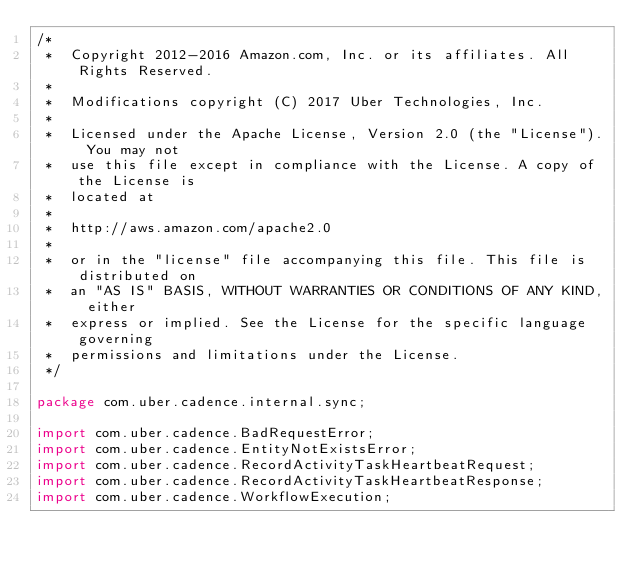Convert code to text. <code><loc_0><loc_0><loc_500><loc_500><_Java_>/*
 *  Copyright 2012-2016 Amazon.com, Inc. or its affiliates. All Rights Reserved.
 *
 *  Modifications copyright (C) 2017 Uber Technologies, Inc.
 *
 *  Licensed under the Apache License, Version 2.0 (the "License"). You may not
 *  use this file except in compliance with the License. A copy of the License is
 *  located at
 *
 *  http://aws.amazon.com/apache2.0
 *
 *  or in the "license" file accompanying this file. This file is distributed on
 *  an "AS IS" BASIS, WITHOUT WARRANTIES OR CONDITIONS OF ANY KIND, either
 *  express or implied. See the License for the specific language governing
 *  permissions and limitations under the License.
 */

package com.uber.cadence.internal.sync;

import com.uber.cadence.BadRequestError;
import com.uber.cadence.EntityNotExistsError;
import com.uber.cadence.RecordActivityTaskHeartbeatRequest;
import com.uber.cadence.RecordActivityTaskHeartbeatResponse;
import com.uber.cadence.WorkflowExecution;</code> 